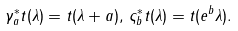<formula> <loc_0><loc_0><loc_500><loc_500>\gamma _ { a } ^ { \ast } t ( \lambda ) = t ( \lambda + a ) , \, \varsigma _ { b } ^ { \ast } t ( \lambda ) = t ( e ^ { b } \lambda ) .</formula> 